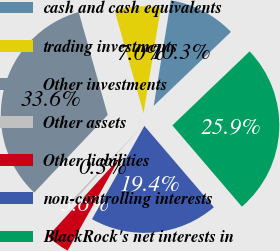Convert chart. <chart><loc_0><loc_0><loc_500><loc_500><pie_chart><fcel>cash and cash equivalents<fcel>trading investments<fcel>Other investments<fcel>Other assets<fcel>Other liabilities<fcel>non-controlling interests<fcel>BlackRock's net interests in<nl><fcel>10.27%<fcel>6.95%<fcel>33.55%<fcel>0.3%<fcel>3.62%<fcel>19.41%<fcel>25.89%<nl></chart> 